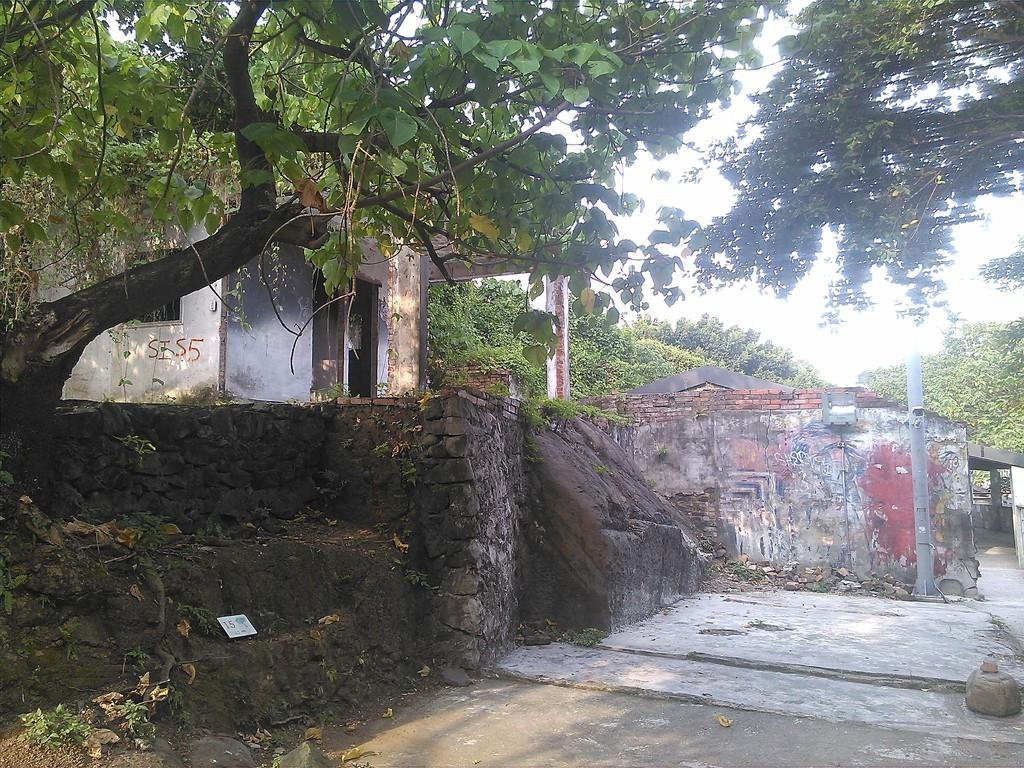What type of natural elements can be seen in the image? There are trees in the image. What type of man-made structures are present in the image? There are houses in the image. What object can be seen standing upright in the image? There is a pole in the image. Can you describe the background of the image? There are other trees visible at the back of the image. What type of brain can be seen in the image? There is no brain present in the image; it features trees, houses, and a pole. What type of calculator can be seen in the image? There is no calculator present in the image. 